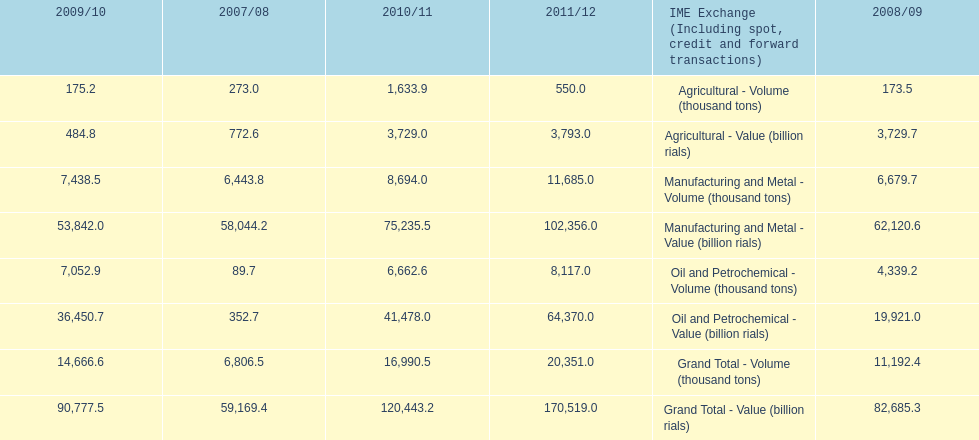In how many years was the value of agriculture, in billion rials, greater than 500 in iran? 4. 